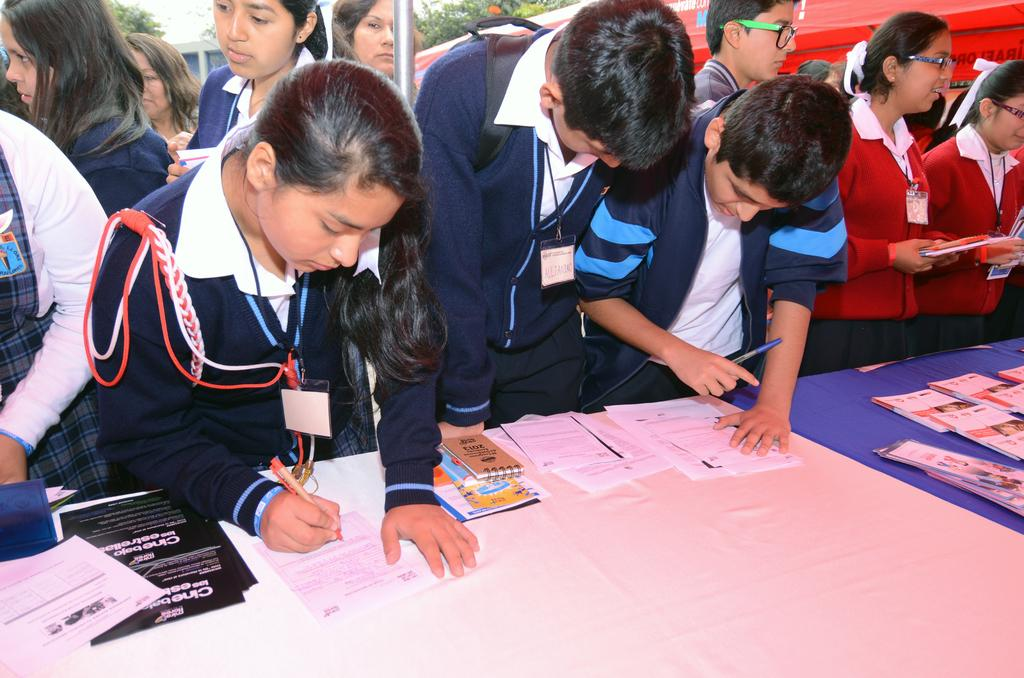How many children are in the image? There are many boys and girls in the image. What are the children wearing? The children are wearing school uniforms. What are the children holding in their hands? The children are holding books and pens. What are the children doing in front of the table? The children are standing in front of a table and signing on papers. What can be seen in the background of the image? There are trees visible in the background of the image. What type of appliance can be seen on the table in the image? There is no appliance present on the table in the image. How long does it take for the children to sign each paper in the image? The provided facts do not give information about the time it takes for the children to sign each paper, so we cannot answer this question. 